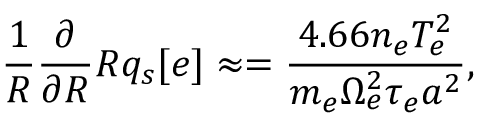Convert formula to latex. <formula><loc_0><loc_0><loc_500><loc_500>\frac { 1 } { R } { \frac { \partial } { \partial R } } R q _ { s } [ e ] \approx = \frac { 4 . 6 6 n _ { e } T _ { e } ^ { 2 } } { m _ { e } \Omega _ { e } ^ { 2 } \tau _ { e } a ^ { 2 } } ,</formula> 